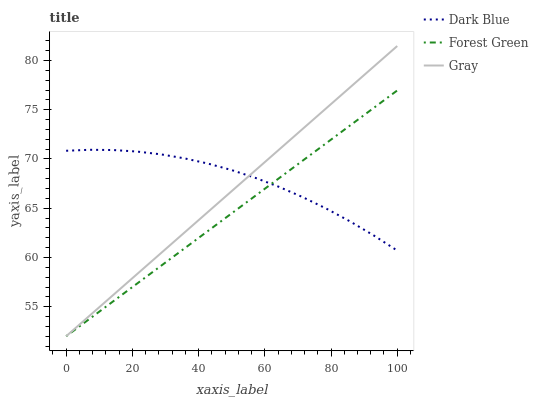Does Forest Green have the minimum area under the curve?
Answer yes or no. Yes. Does Dark Blue have the maximum area under the curve?
Answer yes or no. Yes. Does Gray have the minimum area under the curve?
Answer yes or no. No. Does Gray have the maximum area under the curve?
Answer yes or no. No. Is Forest Green the smoothest?
Answer yes or no. Yes. Is Dark Blue the roughest?
Answer yes or no. Yes. Is Gray the smoothest?
Answer yes or no. No. Is Gray the roughest?
Answer yes or no. No. Does Forest Green have the lowest value?
Answer yes or no. Yes. Does Gray have the highest value?
Answer yes or no. Yes. Does Forest Green have the highest value?
Answer yes or no. No. Does Gray intersect Forest Green?
Answer yes or no. Yes. Is Gray less than Forest Green?
Answer yes or no. No. Is Gray greater than Forest Green?
Answer yes or no. No. 